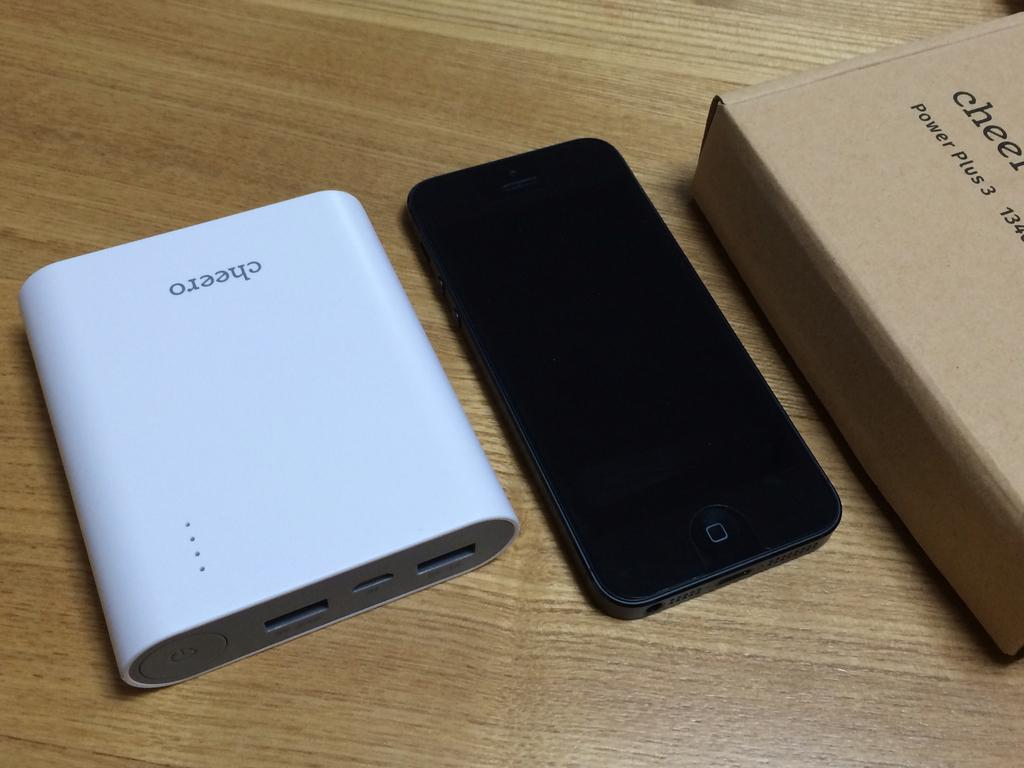<image>
Describe the image concisely. The Cheero power bank sits next to a phone and the Cheero box. 